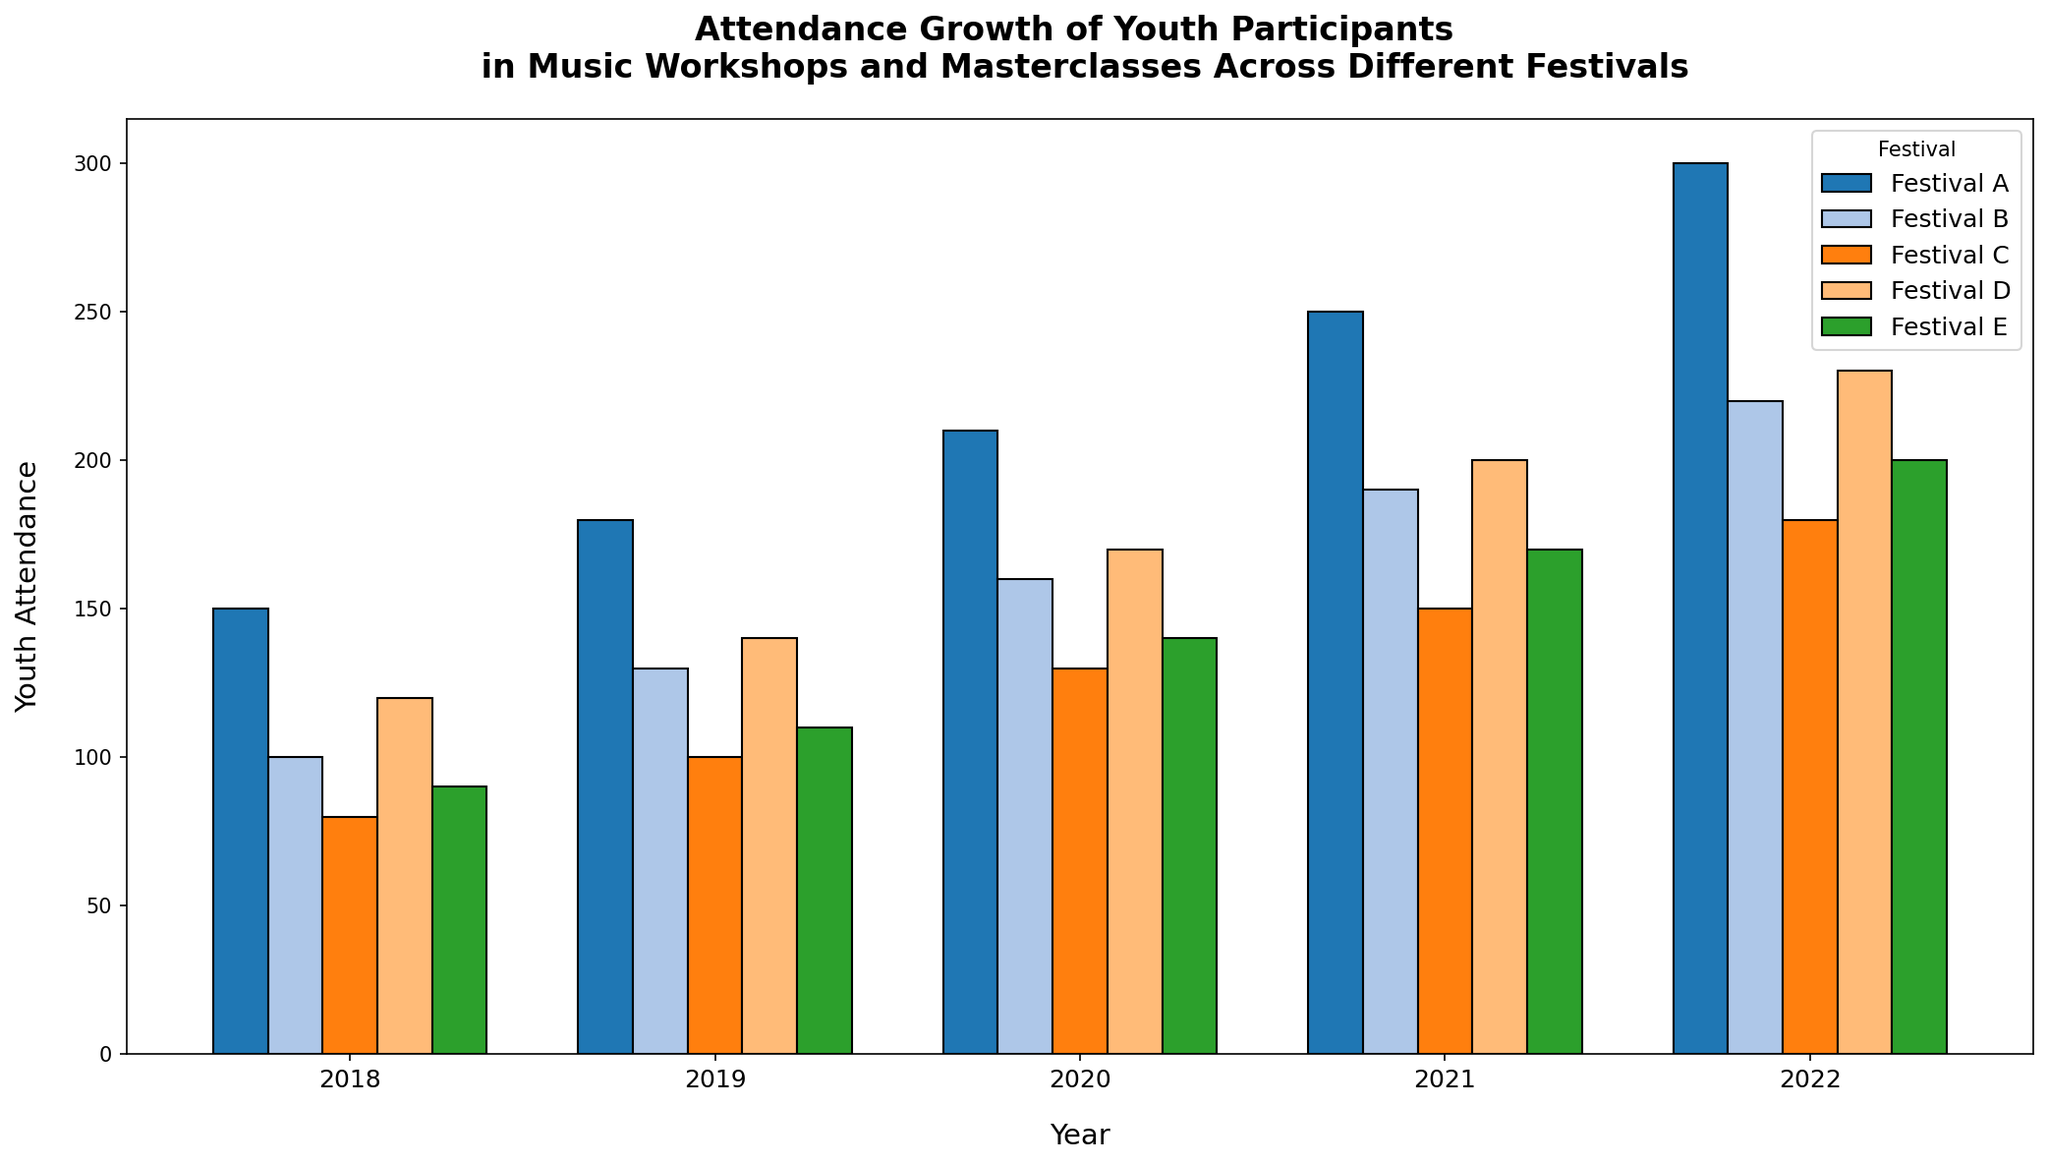What festival had the highest youth attendance in 2022? To find the festival with the highest youth attendance in 2022, look at the heights of the bars labelled 2022. The tallest bar corresponds to Festival A.
Answer: Festival A How did the youth attendance in Festival B change from 2018 to 2022? Look at the height of the bars for Festival B from 2018 to 2022. The heights increase from 100 to 220, indicating growth. Subtract the 2018 value from the 2022 value (220 - 100 = 120).
Answer: Increased by 120 Between 2019 and 2021, which festival showed the greatest numerical increase in youth attendance? For each festival, subtract the 2019 value from the 2021 value and compare the differences. Festival A: 250-180 = 70, Festival B: 190-130 = 60, Festival C: 150-100 = 50, Festival D: 200-140 = 60, Festival E: 170-110 = 60. The greatest difference is for Festival A (70).
Answer: Festival A Which festival had the smallest growth in youth attendance from 2018 to 2022? Look at the difference in bar heights for each festival from 2018 to 2022. Calculations show: Festival A: 300-150 = 150, Festival B: 220-100 = 120, Festival C: 180-80 = 100, Festival D: 230-120 = 110, Festival E: 200-90 = 110. Festival C has the smallest growth of 100.
Answer: Festival C What was the total youth attendance across all festivals in 2020? Sum the heights of all the bars for 2020: Festival A: 210, Festival B: 160, Festival C: 130, Festival D: 170, Festival E: 140. The total is 210 + 160 + 130 + 170 + 140 = 810.
Answer: 810 In which year did Festival D see the highest attendance, and what was the value? Look at the heights of the bars for Festival D across all years. The tallest bar is in 2022 with a height of 230.
Answer: 2022, 230 Compare the youth attendance in Festival A and Festival E in 2018. Which one had more, and by how much? The height of the bars for Festival A in 2018 is 150 and for Festival E is 90. The difference is 150 - 90 = 60.
Answer: Festival A by 60 What was the average youth attendance for Festival C over the five years? Add up the youth attendance for Festival C over 2018-2022 and divide by 5: (80 + 100 + 130 + 150 + 180) / 5 = 640 / 5 = 128.
Answer: 128 Which festival had steady growth in youth attendance across the years? Examine the bars for each festival and note the yearly increments. All festivals show growth, but for an example: Festival D shows a steady increase (120, 140, 170, 200, 230).
Answer: Festival D 